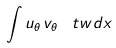Convert formula to latex. <formula><loc_0><loc_0><loc_500><loc_500>\int u _ { \theta } \, v _ { \theta } \, \ t w d x</formula> 